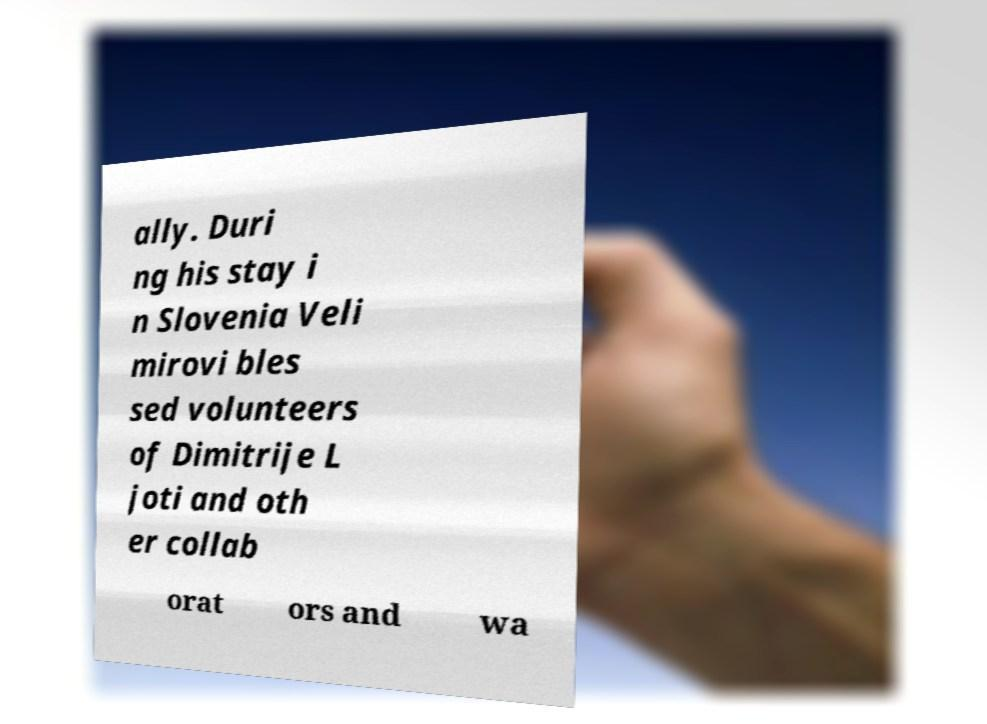Please identify and transcribe the text found in this image. ally. Duri ng his stay i n Slovenia Veli mirovi bles sed volunteers of Dimitrije L joti and oth er collab orat ors and wa 